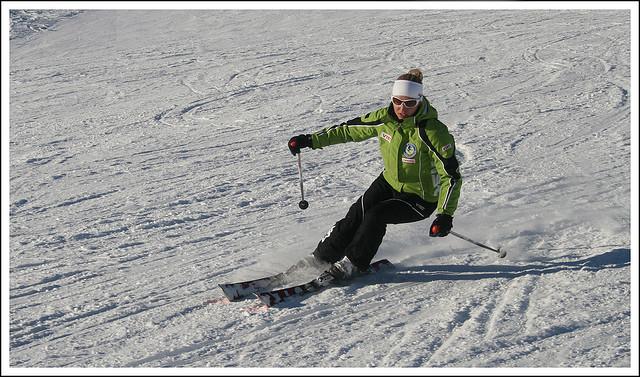How is she keeping her ears warm?
Quick response, please. Headband. What color is her coat?
Concise answer only. Green. Is she leaning to the left or right?
Short answer required. Left. 